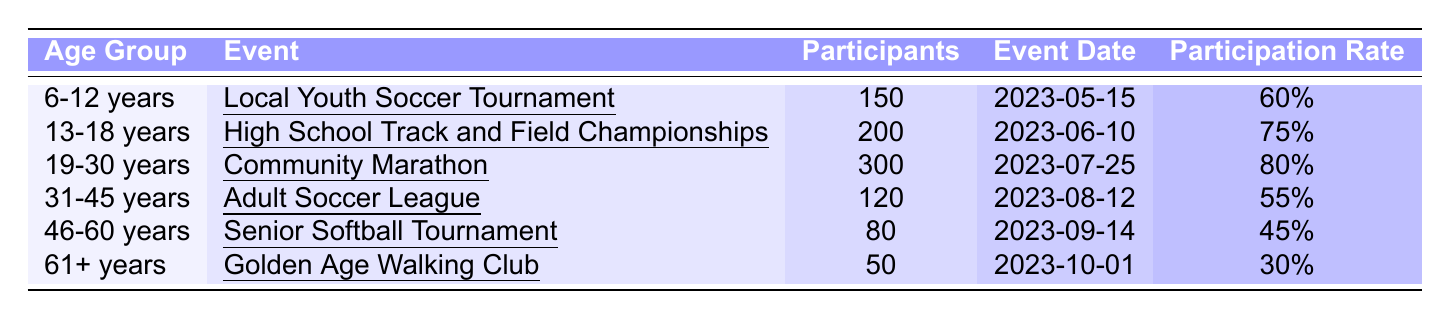What is the participation rate for the "Local Youth Soccer Tournament"? The table shows the participation rate for the "Local Youth Soccer Tournament" under the age group "6-12 years" is listed as 60%.
Answer: 60% Which age group has the highest number of participants? By comparing the entries, the age group "19-30 years" has the highest number of participants at 300 in the "Community Marathon."
Answer: 19-30 years What is the average participation rate across all age groups? To find the average, add the participation rates: 60% + 75% + 80% + 55% + 45% + 30% = 345%. Divide by 6 (the number of age groups) to find the average: 345% / 6 = 57.5%.
Answer: 57.5% How many participants were there in the "Senior Softball Tournament"? The table states that the "Senior Softball Tournament" had 80 participants listed under the age group "46-60 years."
Answer: 80 Is the participation rate for the "Golden Age Walking Club" higher than the "Adult Soccer League"? The participation rate for the "Golden Age Walking Club" is 30%, while it is 55% for the "Adult Soccer League," thus it is not higher.
Answer: No What is the total number of participants from all events? Adding all participants together gives: 150 + 200 + 300 + 120 + 80 + 50 = 900 participants from all events.
Answer: 900 In which event did the "13-18 years" age group participate, and what was the date? The "13-18 years" age group participated in the "High School Track and Field Championships" on the date 2023-06-10, as shown in the table.
Answer: High School Track and Field Championships, 2023-06-10 Which age group had the lowest participation rate, and what is that rate? The age group "61+ years" had the lowest participation rate at 30%, as indicated in the table.
Answer: 61+ years, 30% If you combine the participation of the "31-45 years" and "46-60 years" age groups, how many total participants would that be? The "31-45 years" age group had 120 participants, and the "46-60 years" age group had 80 participants. Summing these up: 120 + 80 = 200 participants.
Answer: 200 What percentage of participants in the "Community Marathon" were from the "19-30 years" age group? Since the "Community Marathon" is for the "19-30 years" age group, the participation is 100% for this group in this event.
Answer: 100% 